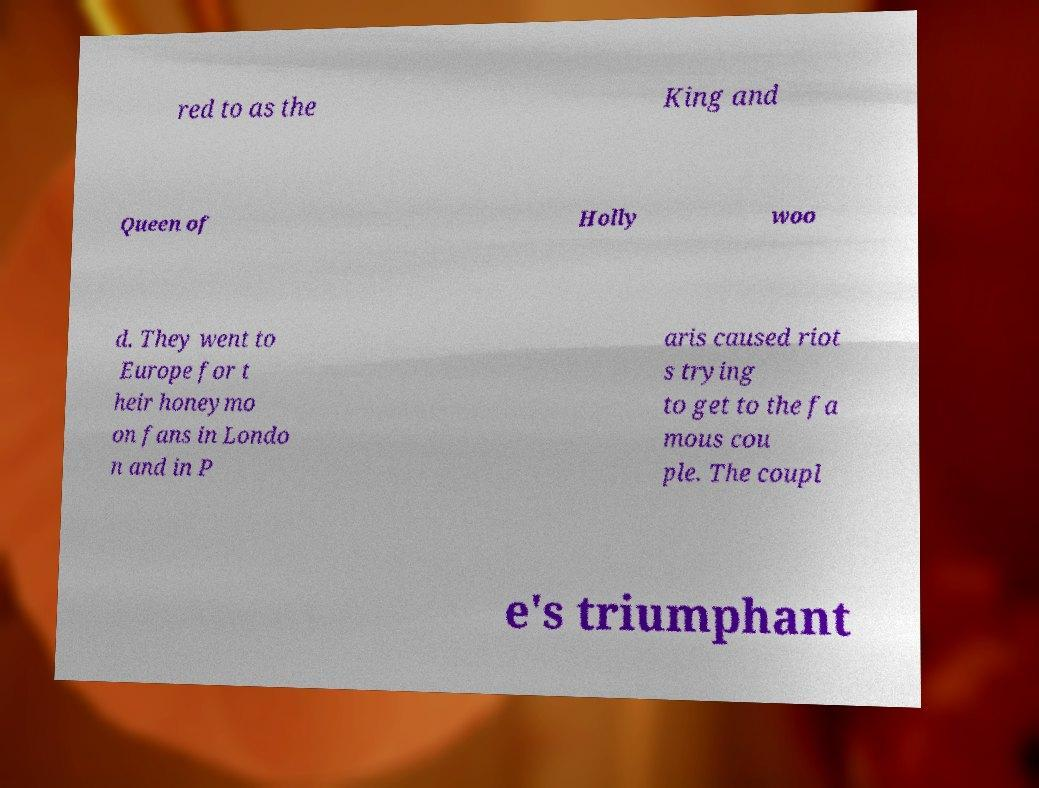Could you extract and type out the text from this image? red to as the King and Queen of Holly woo d. They went to Europe for t heir honeymo on fans in Londo n and in P aris caused riot s trying to get to the fa mous cou ple. The coupl e's triumphant 